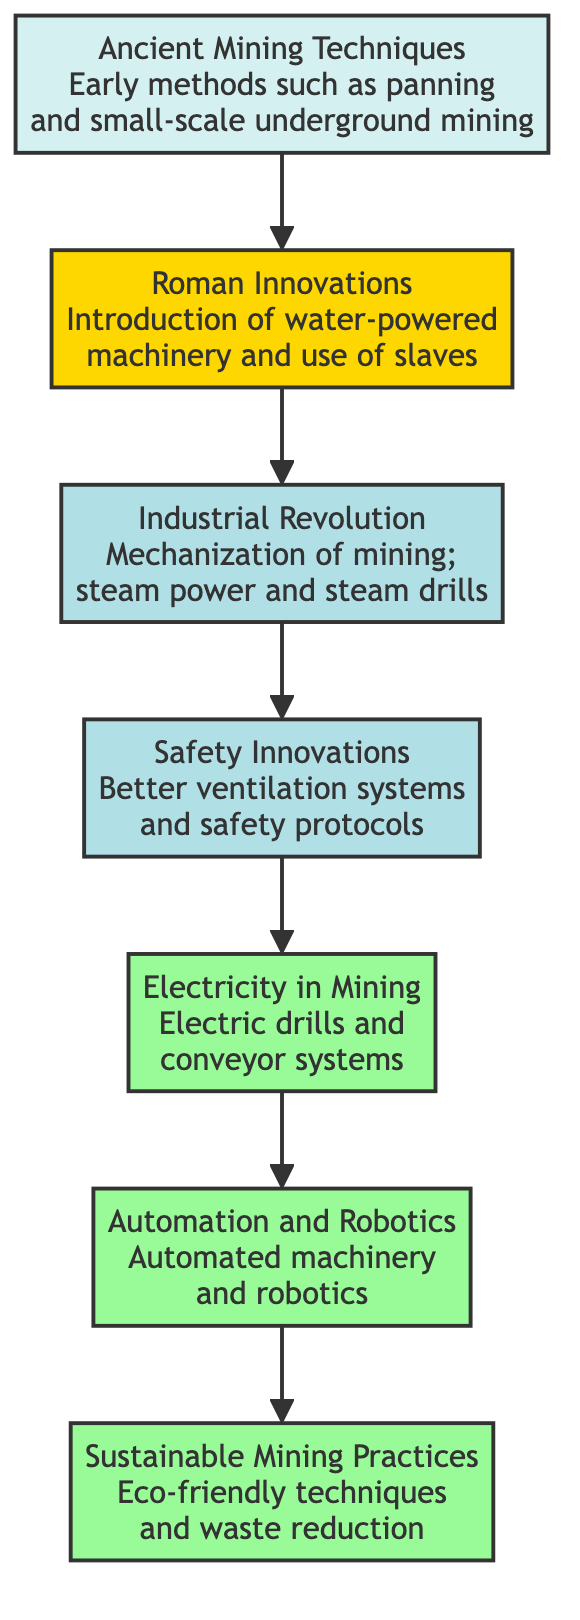What is the starting point of the mining techniques evolution? The starting point of the evolution is the "Ancient Mining Techniques" node, which is the first element in the diagram without any preceding influences.
Answer: Ancient Mining Techniques How many key innovations directly follow Safety Innovations? The diagram shows that "Safety Innovations" leads directly to one subsequent innovation, which is "Electricity in Mining," indicating there is one innovation that directly follows it.
Answer: 1 What is the last node in the evolution of mining techniques? The last node in the diagram is "Sustainable Mining Practices," which does not influence any other nodes. Hence, it is the final evolution in this sequence.
Answer: Sustainable Mining Practices Which innovation introduced electric drills? The node labeled "Electricity in Mining" specifically mentions the introduction of electric drills, making it the correct answer.
Answer: Electricity in Mining What directly influences Automation? The node "Electricity in Mining" influences "Automation," as indicated by the directed edge connecting the two nodes in the diagram.
Answer: Electricity in Mining How many nodes are in the diagram? The diagram contains a total of 7 nodes representing different innovations in the historical evolution of mining techniques.
Answer: 7 What was a significant change introduced during the Industrial Revolution? The node "Mining Boom" describes the mechanization of mining with steam power and steam drills, which were significant changes during this period.
Answer: Mechanization of mining Which technique developed better ventilation systems? The "Safety Innovations" node contains information regarding the development of better ventilation systems for mining, which answers the question.
Answer: Safety Innovations What type of mining practices emerged after the introduction of Robotics? Following the node "Automation," the evolution leads to "Sustainable Mining Practices," indicating the emergence of eco-friendly techniques.
Answer: Sustainable Mining Practices 